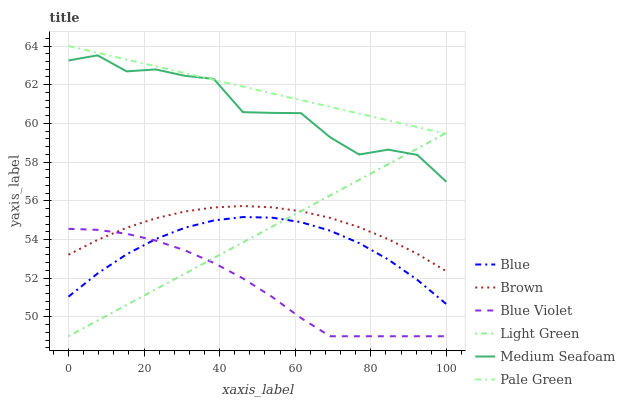Does Blue Violet have the minimum area under the curve?
Answer yes or no. Yes. Does Pale Green have the maximum area under the curve?
Answer yes or no. Yes. Does Brown have the minimum area under the curve?
Answer yes or no. No. Does Brown have the maximum area under the curve?
Answer yes or no. No. Is Light Green the smoothest?
Answer yes or no. Yes. Is Medium Seafoam the roughest?
Answer yes or no. Yes. Is Brown the smoothest?
Answer yes or no. No. Is Brown the roughest?
Answer yes or no. No. Does Light Green have the lowest value?
Answer yes or no. Yes. Does Brown have the lowest value?
Answer yes or no. No. Does Pale Green have the highest value?
Answer yes or no. Yes. Does Brown have the highest value?
Answer yes or no. No. Is Blue Violet less than Medium Seafoam?
Answer yes or no. Yes. Is Pale Green greater than Brown?
Answer yes or no. Yes. Does Blue intersect Light Green?
Answer yes or no. Yes. Is Blue less than Light Green?
Answer yes or no. No. Is Blue greater than Light Green?
Answer yes or no. No. Does Blue Violet intersect Medium Seafoam?
Answer yes or no. No. 